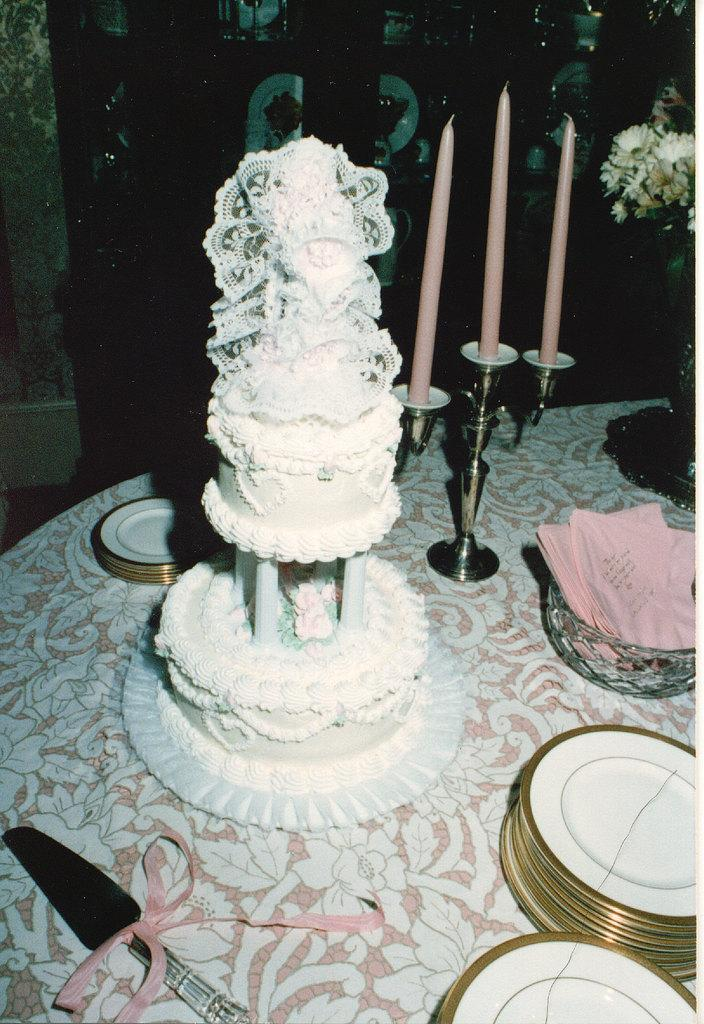What type of cake is visible in the image? There is a step cake in the image. What items are present for serving or eating the cake? Plates and a knife are visible in the image. What additional decorative elements are present in the image? Candles are present in the image. What other objects can be seen on the table in the image? There is a bowl, papers, and a flower vase in the image. What is the color of the background in the image? The background of the image is dark. What page is the person reading from in the image? There is no person reading a page in the image; it only features a table with various objects. 